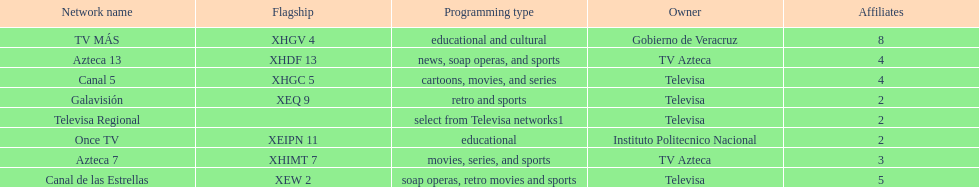Which owner has the most networks? Televisa. 